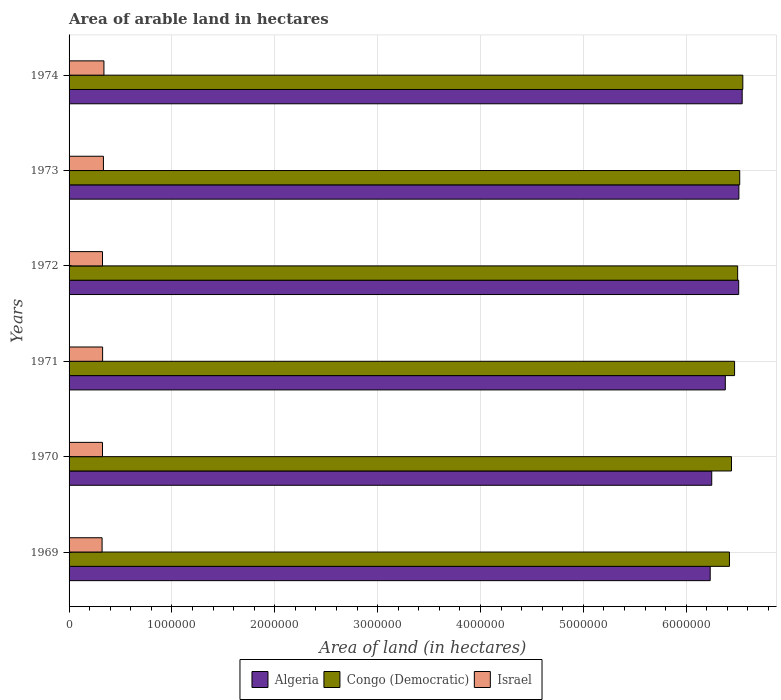How many different coloured bars are there?
Provide a succinct answer. 3. Are the number of bars per tick equal to the number of legend labels?
Your answer should be compact. Yes. Are the number of bars on each tick of the Y-axis equal?
Your response must be concise. Yes. What is the label of the 1st group of bars from the top?
Make the answer very short. 1974. In how many cases, is the number of bars for a given year not equal to the number of legend labels?
Provide a short and direct response. 0. What is the total arable land in Congo (Democratic) in 1974?
Your response must be concise. 6.55e+06. Across all years, what is the maximum total arable land in Israel?
Make the answer very short. 3.39e+05. Across all years, what is the minimum total arable land in Israel?
Keep it short and to the point. 3.21e+05. In which year was the total arable land in Congo (Democratic) maximum?
Keep it short and to the point. 1974. In which year was the total arable land in Algeria minimum?
Give a very brief answer. 1969. What is the total total arable land in Congo (Democratic) in the graph?
Your response must be concise. 3.89e+07. What is the difference between the total arable land in Congo (Democratic) in 1971 and that in 1973?
Provide a short and direct response. -5.00e+04. What is the difference between the total arable land in Congo (Democratic) in 1970 and the total arable land in Israel in 1974?
Provide a short and direct response. 6.10e+06. What is the average total arable land in Israel per year?
Provide a succinct answer. 3.28e+05. In the year 1969, what is the difference between the total arable land in Algeria and total arable land in Congo (Democratic)?
Give a very brief answer. -1.87e+05. In how many years, is the total arable land in Algeria greater than 5000000 hectares?
Your answer should be very brief. 6. What is the ratio of the total arable land in Congo (Democratic) in 1971 to that in 1972?
Your answer should be compact. 1. Is the difference between the total arable land in Algeria in 1973 and 1974 greater than the difference between the total arable land in Congo (Democratic) in 1973 and 1974?
Ensure brevity in your answer.  No. What is the difference between the highest and the second highest total arable land in Israel?
Ensure brevity in your answer.  5000. What is the difference between the highest and the lowest total arable land in Israel?
Offer a terse response. 1.80e+04. Is the sum of the total arable land in Israel in 1969 and 1974 greater than the maximum total arable land in Congo (Democratic) across all years?
Make the answer very short. No. What does the 3rd bar from the top in 1971 represents?
Ensure brevity in your answer.  Algeria. What does the 2nd bar from the bottom in 1970 represents?
Make the answer very short. Congo (Democratic). Are all the bars in the graph horizontal?
Provide a short and direct response. Yes. How many years are there in the graph?
Provide a short and direct response. 6. What is the difference between two consecutive major ticks on the X-axis?
Offer a terse response. 1.00e+06. Are the values on the major ticks of X-axis written in scientific E-notation?
Provide a succinct answer. No. Does the graph contain grids?
Your response must be concise. Yes. Where does the legend appear in the graph?
Make the answer very short. Bottom center. How many legend labels are there?
Offer a very short reply. 3. What is the title of the graph?
Make the answer very short. Area of arable land in hectares. What is the label or title of the X-axis?
Make the answer very short. Area of land (in hectares). What is the label or title of the Y-axis?
Your answer should be very brief. Years. What is the Area of land (in hectares) of Algeria in 1969?
Offer a terse response. 6.23e+06. What is the Area of land (in hectares) of Congo (Democratic) in 1969?
Offer a terse response. 6.42e+06. What is the Area of land (in hectares) in Israel in 1969?
Your response must be concise. 3.21e+05. What is the Area of land (in hectares) of Algeria in 1970?
Provide a short and direct response. 6.25e+06. What is the Area of land (in hectares) in Congo (Democratic) in 1970?
Ensure brevity in your answer.  6.44e+06. What is the Area of land (in hectares) of Israel in 1970?
Keep it short and to the point. 3.25e+05. What is the Area of land (in hectares) of Algeria in 1971?
Offer a terse response. 6.38e+06. What is the Area of land (in hectares) of Congo (Democratic) in 1971?
Offer a very short reply. 6.47e+06. What is the Area of land (in hectares) in Israel in 1971?
Provide a succinct answer. 3.26e+05. What is the Area of land (in hectares) of Algeria in 1972?
Keep it short and to the point. 6.51e+06. What is the Area of land (in hectares) in Congo (Democratic) in 1972?
Ensure brevity in your answer.  6.50e+06. What is the Area of land (in hectares) of Israel in 1972?
Your answer should be very brief. 3.25e+05. What is the Area of land (in hectares) in Algeria in 1973?
Offer a very short reply. 6.51e+06. What is the Area of land (in hectares) in Congo (Democratic) in 1973?
Provide a short and direct response. 6.52e+06. What is the Area of land (in hectares) of Israel in 1973?
Provide a succinct answer. 3.34e+05. What is the Area of land (in hectares) in Algeria in 1974?
Make the answer very short. 6.54e+06. What is the Area of land (in hectares) of Congo (Democratic) in 1974?
Keep it short and to the point. 6.55e+06. What is the Area of land (in hectares) of Israel in 1974?
Provide a succinct answer. 3.39e+05. Across all years, what is the maximum Area of land (in hectares) of Algeria?
Provide a short and direct response. 6.54e+06. Across all years, what is the maximum Area of land (in hectares) in Congo (Democratic)?
Provide a succinct answer. 6.55e+06. Across all years, what is the maximum Area of land (in hectares) of Israel?
Give a very brief answer. 3.39e+05. Across all years, what is the minimum Area of land (in hectares) in Algeria?
Provide a succinct answer. 6.23e+06. Across all years, what is the minimum Area of land (in hectares) of Congo (Democratic)?
Ensure brevity in your answer.  6.42e+06. Across all years, what is the minimum Area of land (in hectares) of Israel?
Provide a succinct answer. 3.21e+05. What is the total Area of land (in hectares) in Algeria in the graph?
Your answer should be very brief. 3.84e+07. What is the total Area of land (in hectares) in Congo (Democratic) in the graph?
Your response must be concise. 3.89e+07. What is the total Area of land (in hectares) of Israel in the graph?
Give a very brief answer. 1.97e+06. What is the difference between the Area of land (in hectares) of Algeria in 1969 and that in 1970?
Make the answer very short. -1.50e+04. What is the difference between the Area of land (in hectares) in Congo (Democratic) in 1969 and that in 1970?
Provide a succinct answer. -2.00e+04. What is the difference between the Area of land (in hectares) of Israel in 1969 and that in 1970?
Give a very brief answer. -4000. What is the difference between the Area of land (in hectares) in Algeria in 1969 and that in 1971?
Keep it short and to the point. -1.47e+05. What is the difference between the Area of land (in hectares) of Israel in 1969 and that in 1971?
Your response must be concise. -5000. What is the difference between the Area of land (in hectares) of Algeria in 1969 and that in 1972?
Give a very brief answer. -2.77e+05. What is the difference between the Area of land (in hectares) of Israel in 1969 and that in 1972?
Offer a very short reply. -4000. What is the difference between the Area of land (in hectares) of Algeria in 1969 and that in 1973?
Ensure brevity in your answer.  -2.79e+05. What is the difference between the Area of land (in hectares) of Congo (Democratic) in 1969 and that in 1973?
Your answer should be very brief. -1.00e+05. What is the difference between the Area of land (in hectares) of Israel in 1969 and that in 1973?
Your response must be concise. -1.30e+04. What is the difference between the Area of land (in hectares) in Algeria in 1969 and that in 1974?
Your response must be concise. -3.11e+05. What is the difference between the Area of land (in hectares) of Israel in 1969 and that in 1974?
Your answer should be compact. -1.80e+04. What is the difference between the Area of land (in hectares) in Algeria in 1970 and that in 1971?
Keep it short and to the point. -1.32e+05. What is the difference between the Area of land (in hectares) of Congo (Democratic) in 1970 and that in 1971?
Ensure brevity in your answer.  -3.00e+04. What is the difference between the Area of land (in hectares) in Israel in 1970 and that in 1971?
Ensure brevity in your answer.  -1000. What is the difference between the Area of land (in hectares) in Algeria in 1970 and that in 1972?
Offer a terse response. -2.62e+05. What is the difference between the Area of land (in hectares) of Algeria in 1970 and that in 1973?
Ensure brevity in your answer.  -2.64e+05. What is the difference between the Area of land (in hectares) of Congo (Democratic) in 1970 and that in 1973?
Provide a short and direct response. -8.00e+04. What is the difference between the Area of land (in hectares) of Israel in 1970 and that in 1973?
Provide a short and direct response. -9000. What is the difference between the Area of land (in hectares) of Algeria in 1970 and that in 1974?
Offer a terse response. -2.96e+05. What is the difference between the Area of land (in hectares) in Congo (Democratic) in 1970 and that in 1974?
Give a very brief answer. -1.10e+05. What is the difference between the Area of land (in hectares) of Israel in 1970 and that in 1974?
Ensure brevity in your answer.  -1.40e+04. What is the difference between the Area of land (in hectares) in Algeria in 1971 and that in 1972?
Offer a terse response. -1.30e+05. What is the difference between the Area of land (in hectares) in Congo (Democratic) in 1971 and that in 1972?
Your answer should be very brief. -3.00e+04. What is the difference between the Area of land (in hectares) of Israel in 1971 and that in 1972?
Ensure brevity in your answer.  1000. What is the difference between the Area of land (in hectares) in Algeria in 1971 and that in 1973?
Provide a short and direct response. -1.32e+05. What is the difference between the Area of land (in hectares) in Congo (Democratic) in 1971 and that in 1973?
Provide a short and direct response. -5.00e+04. What is the difference between the Area of land (in hectares) of Israel in 1971 and that in 1973?
Ensure brevity in your answer.  -8000. What is the difference between the Area of land (in hectares) in Algeria in 1971 and that in 1974?
Provide a succinct answer. -1.64e+05. What is the difference between the Area of land (in hectares) in Israel in 1971 and that in 1974?
Keep it short and to the point. -1.30e+04. What is the difference between the Area of land (in hectares) of Algeria in 1972 and that in 1973?
Provide a succinct answer. -2000. What is the difference between the Area of land (in hectares) of Congo (Democratic) in 1972 and that in 1973?
Ensure brevity in your answer.  -2.00e+04. What is the difference between the Area of land (in hectares) of Israel in 1972 and that in 1973?
Your answer should be compact. -9000. What is the difference between the Area of land (in hectares) in Algeria in 1972 and that in 1974?
Provide a short and direct response. -3.40e+04. What is the difference between the Area of land (in hectares) in Congo (Democratic) in 1972 and that in 1974?
Provide a short and direct response. -5.00e+04. What is the difference between the Area of land (in hectares) of Israel in 1972 and that in 1974?
Provide a succinct answer. -1.40e+04. What is the difference between the Area of land (in hectares) in Algeria in 1973 and that in 1974?
Give a very brief answer. -3.20e+04. What is the difference between the Area of land (in hectares) in Israel in 1973 and that in 1974?
Keep it short and to the point. -5000. What is the difference between the Area of land (in hectares) of Algeria in 1969 and the Area of land (in hectares) of Congo (Democratic) in 1970?
Provide a succinct answer. -2.07e+05. What is the difference between the Area of land (in hectares) of Algeria in 1969 and the Area of land (in hectares) of Israel in 1970?
Ensure brevity in your answer.  5.91e+06. What is the difference between the Area of land (in hectares) of Congo (Democratic) in 1969 and the Area of land (in hectares) of Israel in 1970?
Offer a very short reply. 6.10e+06. What is the difference between the Area of land (in hectares) in Algeria in 1969 and the Area of land (in hectares) in Congo (Democratic) in 1971?
Make the answer very short. -2.37e+05. What is the difference between the Area of land (in hectares) of Algeria in 1969 and the Area of land (in hectares) of Israel in 1971?
Make the answer very short. 5.91e+06. What is the difference between the Area of land (in hectares) in Congo (Democratic) in 1969 and the Area of land (in hectares) in Israel in 1971?
Your answer should be very brief. 6.09e+06. What is the difference between the Area of land (in hectares) in Algeria in 1969 and the Area of land (in hectares) in Congo (Democratic) in 1972?
Provide a short and direct response. -2.67e+05. What is the difference between the Area of land (in hectares) in Algeria in 1969 and the Area of land (in hectares) in Israel in 1972?
Give a very brief answer. 5.91e+06. What is the difference between the Area of land (in hectares) in Congo (Democratic) in 1969 and the Area of land (in hectares) in Israel in 1972?
Give a very brief answer. 6.10e+06. What is the difference between the Area of land (in hectares) of Algeria in 1969 and the Area of land (in hectares) of Congo (Democratic) in 1973?
Your response must be concise. -2.87e+05. What is the difference between the Area of land (in hectares) in Algeria in 1969 and the Area of land (in hectares) in Israel in 1973?
Offer a very short reply. 5.90e+06. What is the difference between the Area of land (in hectares) in Congo (Democratic) in 1969 and the Area of land (in hectares) in Israel in 1973?
Offer a terse response. 6.09e+06. What is the difference between the Area of land (in hectares) in Algeria in 1969 and the Area of land (in hectares) in Congo (Democratic) in 1974?
Your answer should be very brief. -3.17e+05. What is the difference between the Area of land (in hectares) of Algeria in 1969 and the Area of land (in hectares) of Israel in 1974?
Make the answer very short. 5.89e+06. What is the difference between the Area of land (in hectares) in Congo (Democratic) in 1969 and the Area of land (in hectares) in Israel in 1974?
Provide a short and direct response. 6.08e+06. What is the difference between the Area of land (in hectares) of Algeria in 1970 and the Area of land (in hectares) of Congo (Democratic) in 1971?
Your response must be concise. -2.22e+05. What is the difference between the Area of land (in hectares) of Algeria in 1970 and the Area of land (in hectares) of Israel in 1971?
Make the answer very short. 5.92e+06. What is the difference between the Area of land (in hectares) in Congo (Democratic) in 1970 and the Area of land (in hectares) in Israel in 1971?
Make the answer very short. 6.11e+06. What is the difference between the Area of land (in hectares) of Algeria in 1970 and the Area of land (in hectares) of Congo (Democratic) in 1972?
Your response must be concise. -2.52e+05. What is the difference between the Area of land (in hectares) of Algeria in 1970 and the Area of land (in hectares) of Israel in 1972?
Keep it short and to the point. 5.92e+06. What is the difference between the Area of land (in hectares) in Congo (Democratic) in 1970 and the Area of land (in hectares) in Israel in 1972?
Keep it short and to the point. 6.12e+06. What is the difference between the Area of land (in hectares) of Algeria in 1970 and the Area of land (in hectares) of Congo (Democratic) in 1973?
Give a very brief answer. -2.72e+05. What is the difference between the Area of land (in hectares) of Algeria in 1970 and the Area of land (in hectares) of Israel in 1973?
Make the answer very short. 5.91e+06. What is the difference between the Area of land (in hectares) in Congo (Democratic) in 1970 and the Area of land (in hectares) in Israel in 1973?
Offer a very short reply. 6.11e+06. What is the difference between the Area of land (in hectares) of Algeria in 1970 and the Area of land (in hectares) of Congo (Democratic) in 1974?
Ensure brevity in your answer.  -3.02e+05. What is the difference between the Area of land (in hectares) in Algeria in 1970 and the Area of land (in hectares) in Israel in 1974?
Your answer should be very brief. 5.91e+06. What is the difference between the Area of land (in hectares) in Congo (Democratic) in 1970 and the Area of land (in hectares) in Israel in 1974?
Ensure brevity in your answer.  6.10e+06. What is the difference between the Area of land (in hectares) of Algeria in 1971 and the Area of land (in hectares) of Congo (Democratic) in 1972?
Your answer should be very brief. -1.20e+05. What is the difference between the Area of land (in hectares) in Algeria in 1971 and the Area of land (in hectares) in Israel in 1972?
Provide a short and direct response. 6.06e+06. What is the difference between the Area of land (in hectares) of Congo (Democratic) in 1971 and the Area of land (in hectares) of Israel in 1972?
Give a very brief answer. 6.14e+06. What is the difference between the Area of land (in hectares) in Algeria in 1971 and the Area of land (in hectares) in Congo (Democratic) in 1973?
Offer a terse response. -1.40e+05. What is the difference between the Area of land (in hectares) of Algeria in 1971 and the Area of land (in hectares) of Israel in 1973?
Keep it short and to the point. 6.05e+06. What is the difference between the Area of land (in hectares) of Congo (Democratic) in 1971 and the Area of land (in hectares) of Israel in 1973?
Offer a very short reply. 6.14e+06. What is the difference between the Area of land (in hectares) of Algeria in 1971 and the Area of land (in hectares) of Israel in 1974?
Your answer should be very brief. 6.04e+06. What is the difference between the Area of land (in hectares) in Congo (Democratic) in 1971 and the Area of land (in hectares) in Israel in 1974?
Your answer should be very brief. 6.13e+06. What is the difference between the Area of land (in hectares) of Algeria in 1972 and the Area of land (in hectares) of Israel in 1973?
Make the answer very short. 6.18e+06. What is the difference between the Area of land (in hectares) of Congo (Democratic) in 1972 and the Area of land (in hectares) of Israel in 1973?
Offer a very short reply. 6.17e+06. What is the difference between the Area of land (in hectares) of Algeria in 1972 and the Area of land (in hectares) of Israel in 1974?
Offer a very short reply. 6.17e+06. What is the difference between the Area of land (in hectares) in Congo (Democratic) in 1972 and the Area of land (in hectares) in Israel in 1974?
Provide a succinct answer. 6.16e+06. What is the difference between the Area of land (in hectares) of Algeria in 1973 and the Area of land (in hectares) of Congo (Democratic) in 1974?
Your answer should be compact. -3.80e+04. What is the difference between the Area of land (in hectares) in Algeria in 1973 and the Area of land (in hectares) in Israel in 1974?
Keep it short and to the point. 6.17e+06. What is the difference between the Area of land (in hectares) of Congo (Democratic) in 1973 and the Area of land (in hectares) of Israel in 1974?
Your answer should be compact. 6.18e+06. What is the average Area of land (in hectares) in Algeria per year?
Your response must be concise. 6.40e+06. What is the average Area of land (in hectares) of Congo (Democratic) per year?
Give a very brief answer. 6.48e+06. What is the average Area of land (in hectares) in Israel per year?
Provide a succinct answer. 3.28e+05. In the year 1969, what is the difference between the Area of land (in hectares) in Algeria and Area of land (in hectares) in Congo (Democratic)?
Make the answer very short. -1.87e+05. In the year 1969, what is the difference between the Area of land (in hectares) in Algeria and Area of land (in hectares) in Israel?
Keep it short and to the point. 5.91e+06. In the year 1969, what is the difference between the Area of land (in hectares) of Congo (Democratic) and Area of land (in hectares) of Israel?
Provide a succinct answer. 6.10e+06. In the year 1970, what is the difference between the Area of land (in hectares) in Algeria and Area of land (in hectares) in Congo (Democratic)?
Give a very brief answer. -1.92e+05. In the year 1970, what is the difference between the Area of land (in hectares) of Algeria and Area of land (in hectares) of Israel?
Your response must be concise. 5.92e+06. In the year 1970, what is the difference between the Area of land (in hectares) in Congo (Democratic) and Area of land (in hectares) in Israel?
Your answer should be compact. 6.12e+06. In the year 1971, what is the difference between the Area of land (in hectares) in Algeria and Area of land (in hectares) in Congo (Democratic)?
Keep it short and to the point. -9.00e+04. In the year 1971, what is the difference between the Area of land (in hectares) in Algeria and Area of land (in hectares) in Israel?
Offer a very short reply. 6.05e+06. In the year 1971, what is the difference between the Area of land (in hectares) in Congo (Democratic) and Area of land (in hectares) in Israel?
Give a very brief answer. 6.14e+06. In the year 1972, what is the difference between the Area of land (in hectares) of Algeria and Area of land (in hectares) of Israel?
Give a very brief answer. 6.18e+06. In the year 1972, what is the difference between the Area of land (in hectares) in Congo (Democratic) and Area of land (in hectares) in Israel?
Your answer should be very brief. 6.18e+06. In the year 1973, what is the difference between the Area of land (in hectares) in Algeria and Area of land (in hectares) in Congo (Democratic)?
Give a very brief answer. -8000. In the year 1973, what is the difference between the Area of land (in hectares) in Algeria and Area of land (in hectares) in Israel?
Your answer should be compact. 6.18e+06. In the year 1973, what is the difference between the Area of land (in hectares) in Congo (Democratic) and Area of land (in hectares) in Israel?
Your response must be concise. 6.19e+06. In the year 1974, what is the difference between the Area of land (in hectares) of Algeria and Area of land (in hectares) of Congo (Democratic)?
Keep it short and to the point. -6000. In the year 1974, what is the difference between the Area of land (in hectares) in Algeria and Area of land (in hectares) in Israel?
Offer a very short reply. 6.20e+06. In the year 1974, what is the difference between the Area of land (in hectares) of Congo (Democratic) and Area of land (in hectares) of Israel?
Provide a short and direct response. 6.21e+06. What is the ratio of the Area of land (in hectares) of Congo (Democratic) in 1969 to that in 1970?
Offer a very short reply. 1. What is the ratio of the Area of land (in hectares) in Israel in 1969 to that in 1971?
Your answer should be compact. 0.98. What is the ratio of the Area of land (in hectares) in Algeria in 1969 to that in 1972?
Ensure brevity in your answer.  0.96. What is the ratio of the Area of land (in hectares) in Congo (Democratic) in 1969 to that in 1972?
Make the answer very short. 0.99. What is the ratio of the Area of land (in hectares) of Algeria in 1969 to that in 1973?
Provide a succinct answer. 0.96. What is the ratio of the Area of land (in hectares) in Congo (Democratic) in 1969 to that in 1973?
Your response must be concise. 0.98. What is the ratio of the Area of land (in hectares) in Israel in 1969 to that in 1973?
Ensure brevity in your answer.  0.96. What is the ratio of the Area of land (in hectares) of Algeria in 1969 to that in 1974?
Keep it short and to the point. 0.95. What is the ratio of the Area of land (in hectares) in Congo (Democratic) in 1969 to that in 1974?
Provide a succinct answer. 0.98. What is the ratio of the Area of land (in hectares) of Israel in 1969 to that in 1974?
Your response must be concise. 0.95. What is the ratio of the Area of land (in hectares) of Algeria in 1970 to that in 1971?
Your answer should be compact. 0.98. What is the ratio of the Area of land (in hectares) of Congo (Democratic) in 1970 to that in 1971?
Keep it short and to the point. 1. What is the ratio of the Area of land (in hectares) in Israel in 1970 to that in 1971?
Your answer should be very brief. 1. What is the ratio of the Area of land (in hectares) in Algeria in 1970 to that in 1972?
Provide a short and direct response. 0.96. What is the ratio of the Area of land (in hectares) of Israel in 1970 to that in 1972?
Offer a very short reply. 1. What is the ratio of the Area of land (in hectares) in Algeria in 1970 to that in 1973?
Your response must be concise. 0.96. What is the ratio of the Area of land (in hectares) in Congo (Democratic) in 1970 to that in 1973?
Provide a succinct answer. 0.99. What is the ratio of the Area of land (in hectares) in Israel in 1970 to that in 1973?
Provide a succinct answer. 0.97. What is the ratio of the Area of land (in hectares) in Algeria in 1970 to that in 1974?
Keep it short and to the point. 0.95. What is the ratio of the Area of land (in hectares) in Congo (Democratic) in 1970 to that in 1974?
Give a very brief answer. 0.98. What is the ratio of the Area of land (in hectares) in Israel in 1970 to that in 1974?
Provide a succinct answer. 0.96. What is the ratio of the Area of land (in hectares) of Algeria in 1971 to that in 1972?
Provide a succinct answer. 0.98. What is the ratio of the Area of land (in hectares) in Algeria in 1971 to that in 1973?
Provide a short and direct response. 0.98. What is the ratio of the Area of land (in hectares) in Algeria in 1971 to that in 1974?
Offer a very short reply. 0.97. What is the ratio of the Area of land (in hectares) of Israel in 1971 to that in 1974?
Provide a succinct answer. 0.96. What is the ratio of the Area of land (in hectares) in Congo (Democratic) in 1972 to that in 1973?
Offer a very short reply. 1. What is the ratio of the Area of land (in hectares) in Israel in 1972 to that in 1973?
Your response must be concise. 0.97. What is the ratio of the Area of land (in hectares) of Congo (Democratic) in 1972 to that in 1974?
Your response must be concise. 0.99. What is the ratio of the Area of land (in hectares) of Israel in 1972 to that in 1974?
Keep it short and to the point. 0.96. What is the ratio of the Area of land (in hectares) in Algeria in 1973 to that in 1974?
Provide a short and direct response. 1. What is the difference between the highest and the second highest Area of land (in hectares) of Algeria?
Provide a short and direct response. 3.20e+04. What is the difference between the highest and the second highest Area of land (in hectares) in Israel?
Your answer should be very brief. 5000. What is the difference between the highest and the lowest Area of land (in hectares) of Algeria?
Offer a terse response. 3.11e+05. What is the difference between the highest and the lowest Area of land (in hectares) of Israel?
Offer a very short reply. 1.80e+04. 